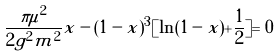Convert formula to latex. <formula><loc_0><loc_0><loc_500><loc_500>\frac { \pi \mu ^ { 2 } } { 2 g ^ { 2 } m ^ { 2 } } x - ( 1 - x ) ^ { 3 } [ \ln ( 1 - x ) + \frac { 1 } { 2 } ] = 0</formula> 